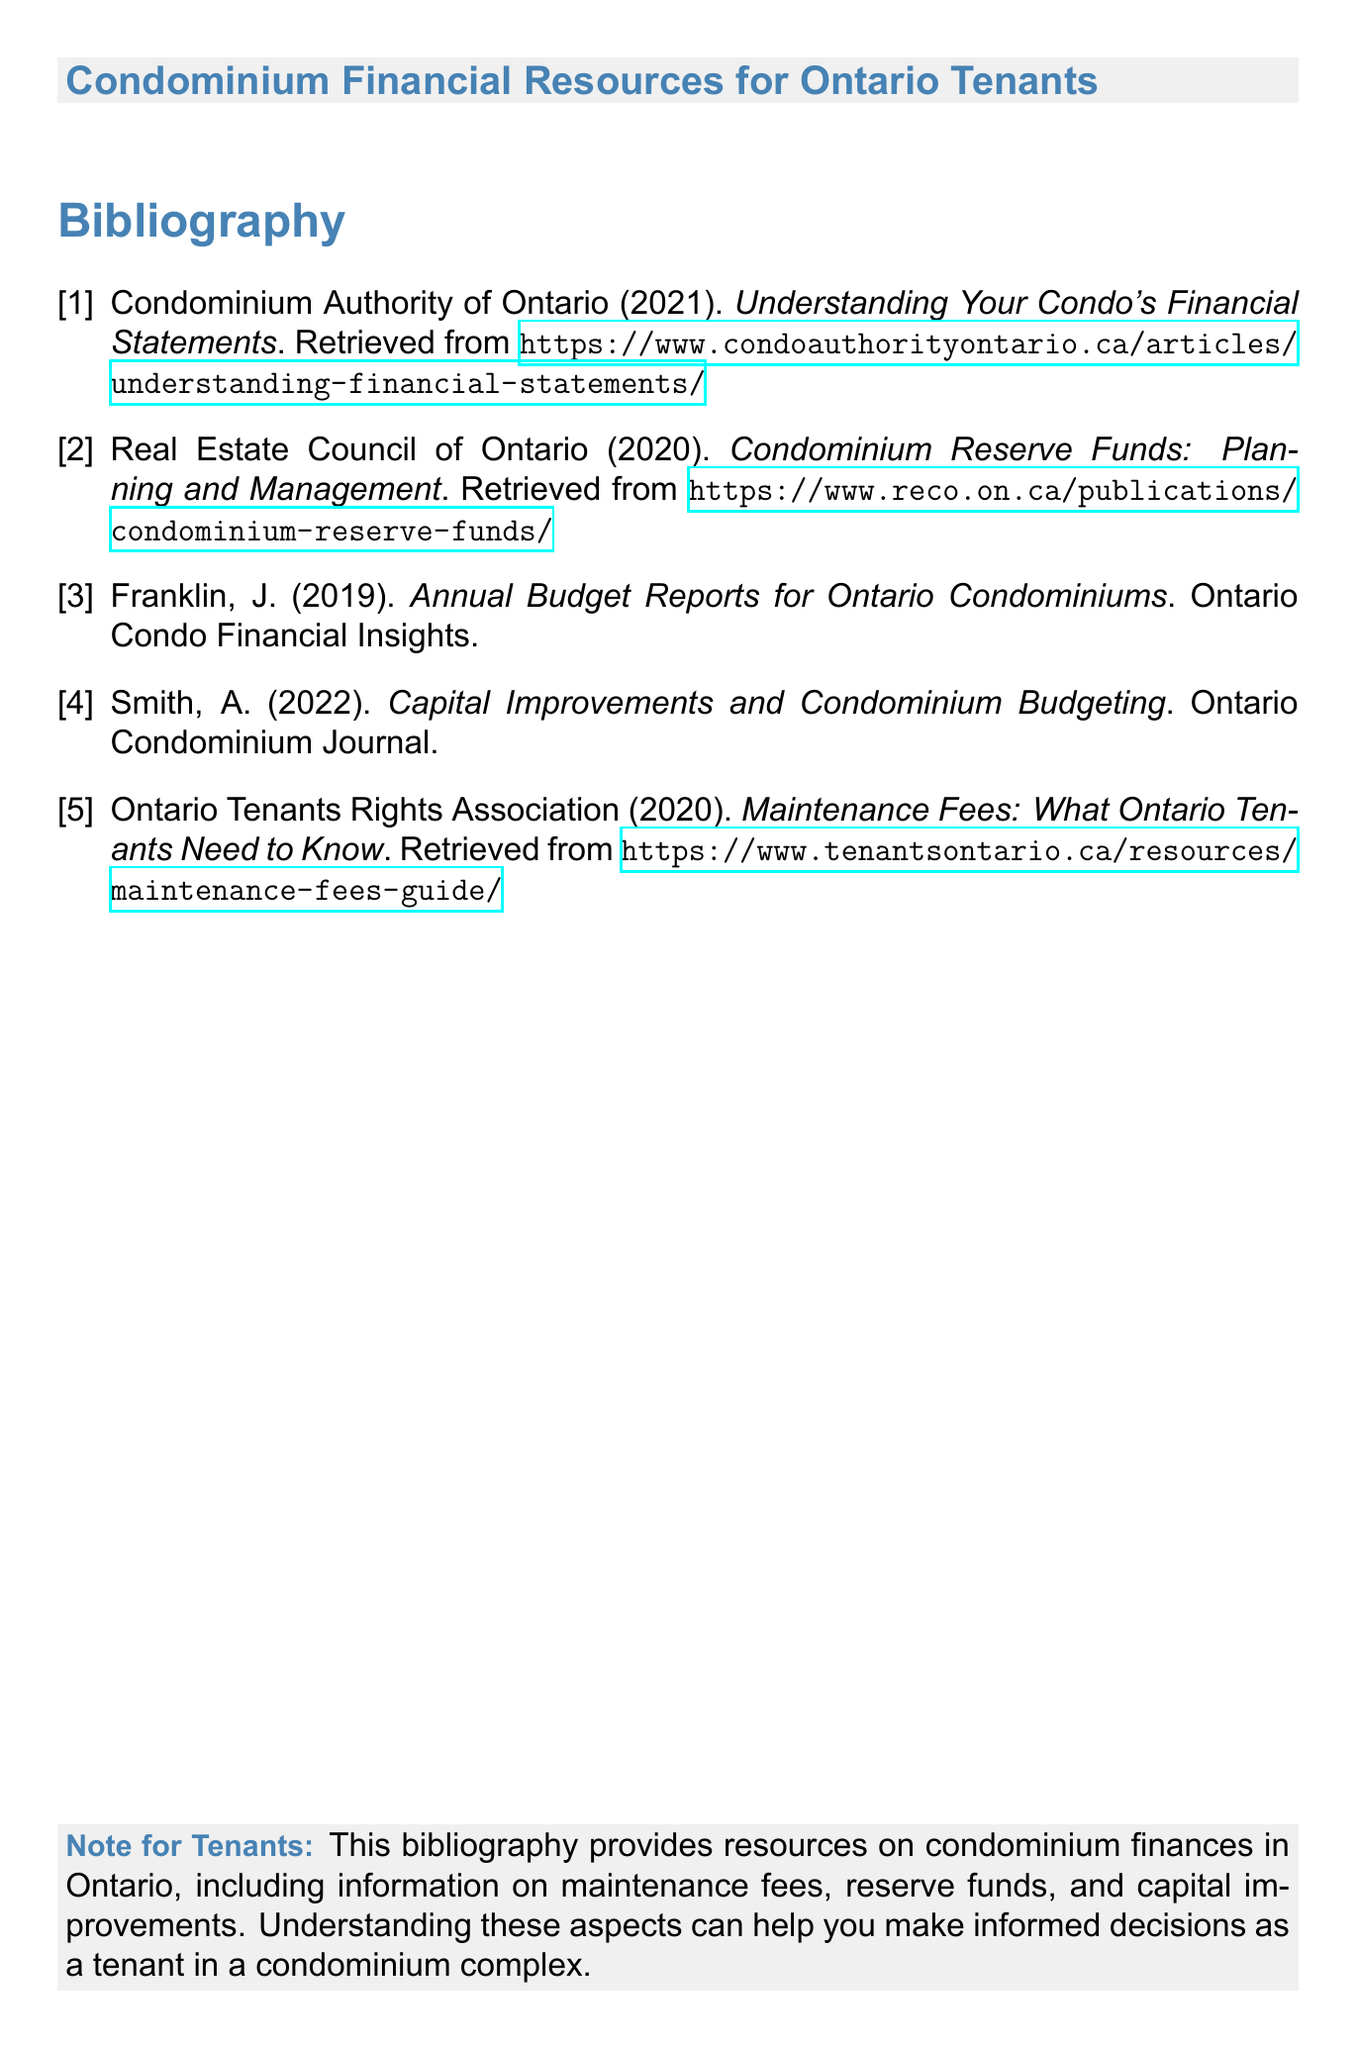What is the title of the document? The title of the document is found in the header section and indicates the content focus.
Answer: Condominium Financial Resources for Ontario Tenants Who authored the 2022 resource on capital improvements? The author of the 2022 resource on capital improvements is indicated in the reference list of the document.
Answer: Smith, A What year did the Condominium Authority of Ontario publish their document? The publication year can be found in the reference citation for the Condominium Authority of Ontario.
Answer: 2021 How many references are listed in the bibliography? The total number of references can be counted from the bibliography section.
Answer: 5 What is one main focus of the resources listed in the bibliography? The focus is summarized in the note for tenants at the end of the document, reflecting the overall content.
Answer: Maintenance fees What URL leads to the resource about maintenance fees? The URL can be extracted from the reference list related to maintenance fees.
Answer: https://www.tenantsontario.ca/resources/maintenance-fees-guide/ What type of document is this? This document is characterized by its structure and purpose, as indicated in the title.
Answer: Bibliography What publication year was mentioned for the resource on reserve funds? The publication year for the reserve funds resource is stated in the reference section.
Answer: 2020 